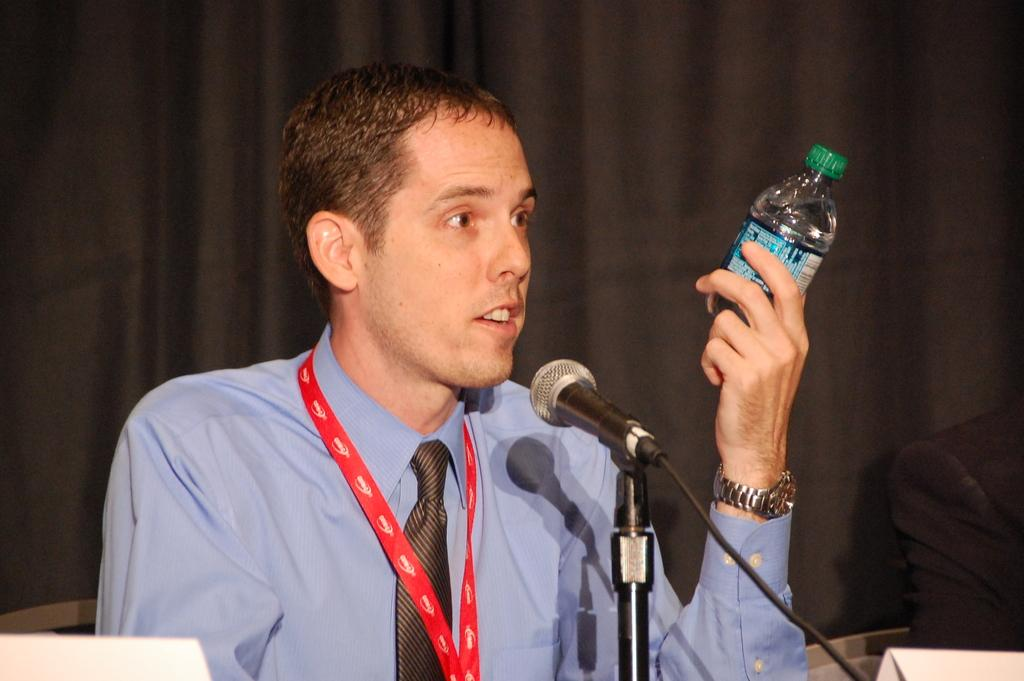Who is present in the image? There is a man in the image. What is the man holding in the image? The man is holding a bottle. What is the man doing with the bottle? The man is looking at the bottle. What object is in front of the man? There is a microphone in front of the man. What can be seen in the background of the image? There is a curtain in the background of the image. What type of grass is growing on the man's head in the image? There is no grass present in the image, and the man's head is not mentioned as having any grass growing on it. 